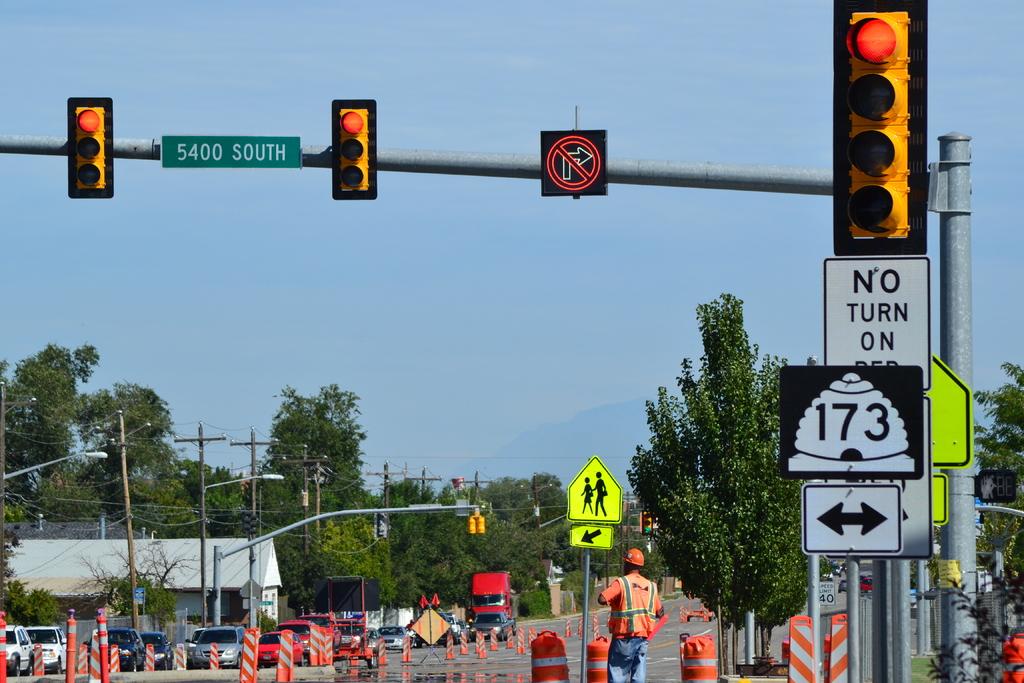Where can you not turn on red?
Keep it short and to the point. Right. What is the name of the street?
Your answer should be very brief. 5400 south. 